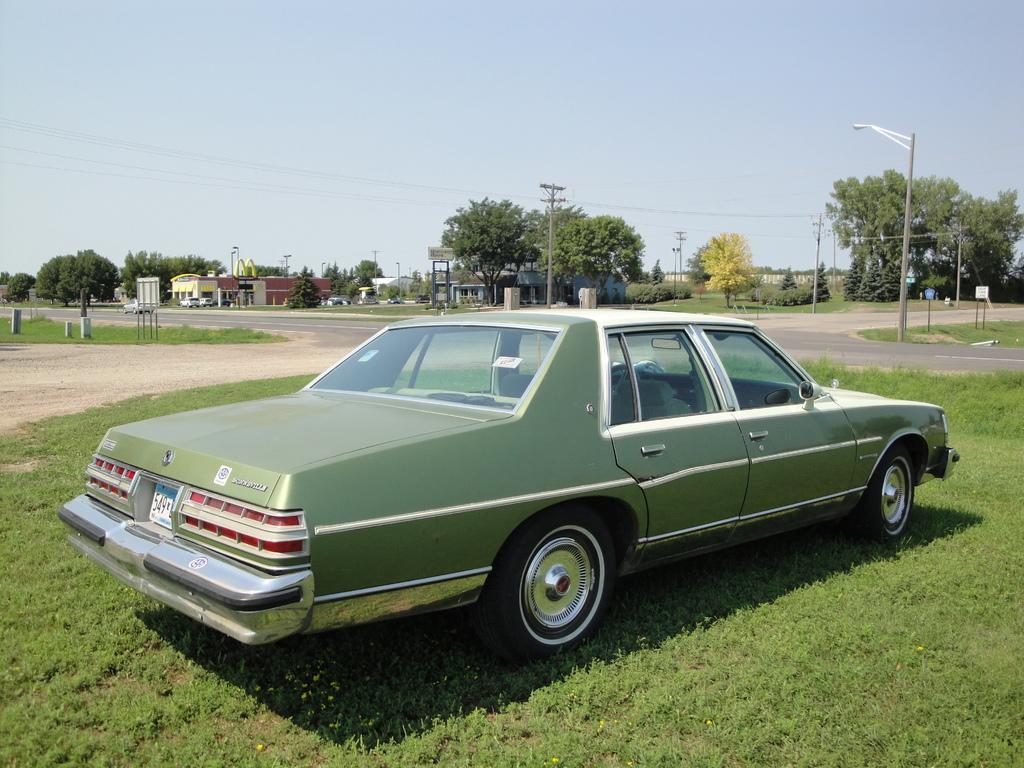Where is the car located in the image? The car is parked on the grass in the image. What can be seen in the distance behind the car? There are buildings, utility poles, trees, and the sky visible in the background. How many types of structures can be seen in the background? There are three types of structures visible in the background: buildings, utility poles, and trees. How many rings are hanging from the trees in the image? There are no rings hanging from the trees in the image; only the trees themselves are visible. 